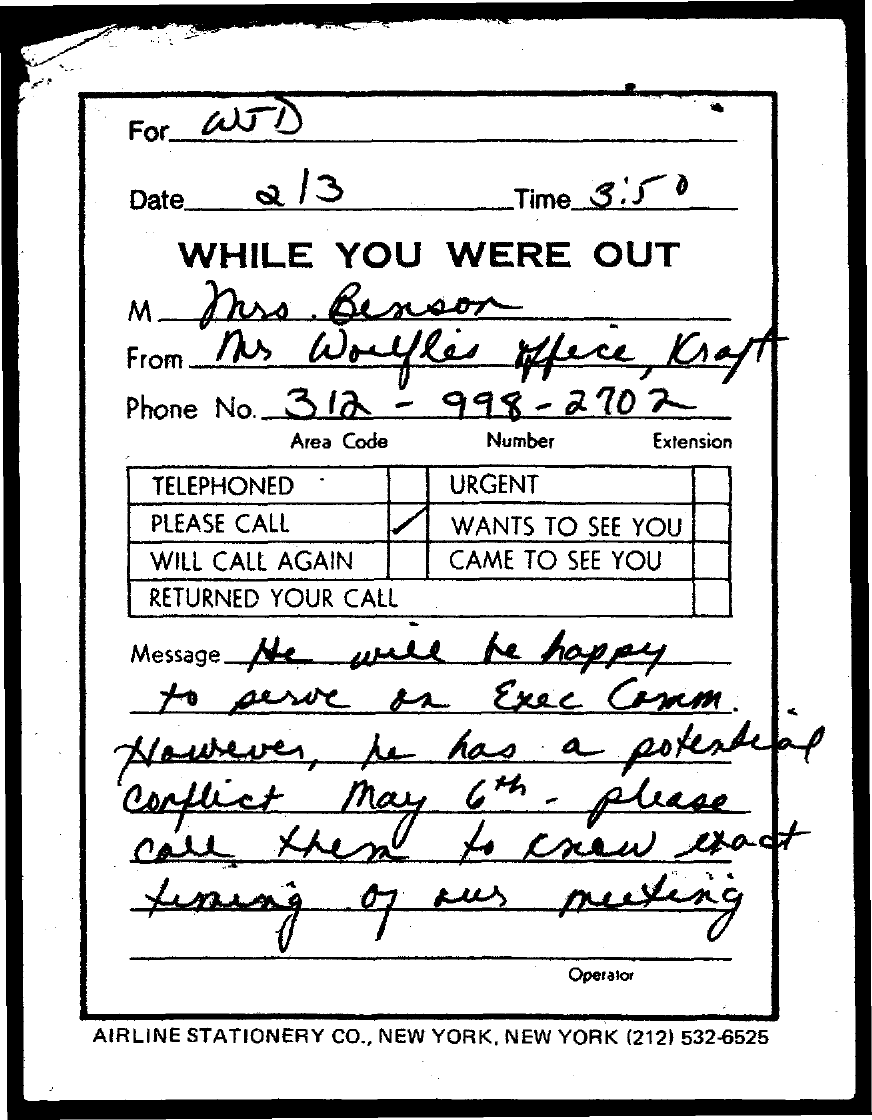Who is the for?
Keep it short and to the point. WJD. What is the Date?
Give a very brief answer. 2 / 3. What is the time?
Give a very brief answer. 3:50. What is the Phone No.?
Your answer should be very brief. 312-998-2702. When does he have a potential conflict?
Give a very brief answer. May 6th. 